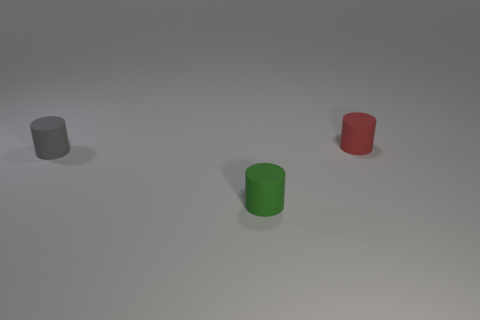Add 2 large purple metal balls. How many objects exist? 5 Subtract all brown things. Subtract all small matte cylinders. How many objects are left? 0 Add 1 gray cylinders. How many gray cylinders are left? 2 Add 1 small green cylinders. How many small green cylinders exist? 2 Subtract 0 gray balls. How many objects are left? 3 